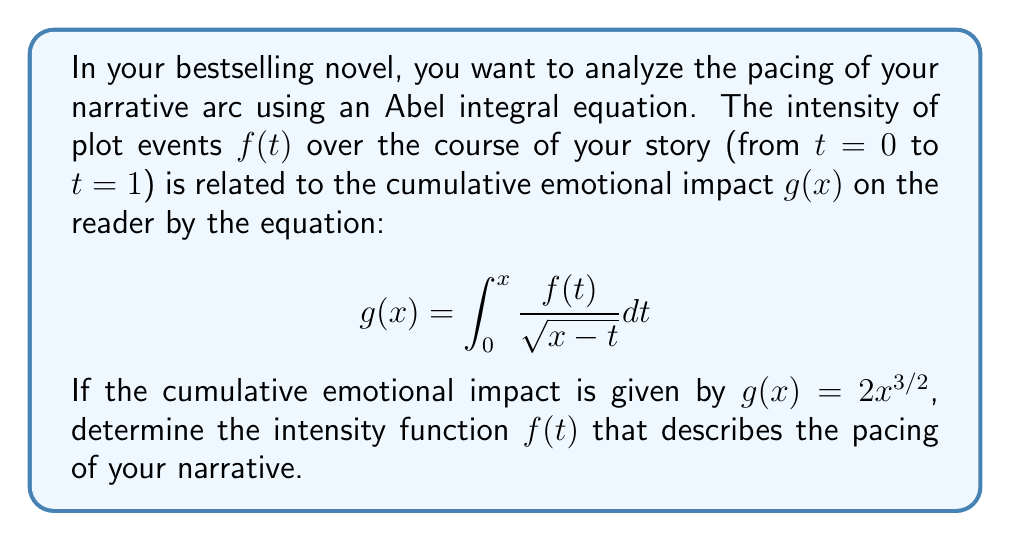Could you help me with this problem? To solve this Abel integral equation and find $f(t)$, we'll follow these steps:

1) The general form of an Abel integral equation is:

   $$g(x) = \int_0^x \frac{f(t)}{\sqrt{x-t}} dt$$

2) The solution to this equation is given by:

   $$f(t) = \frac{1}{\pi} \frac{d}{dt} \int_0^t \frac{g'(x)}{\sqrt{t-x}} dx$$

3) In our case, $g(x) = 2x^{3/2}$. We need to find $g'(x)$:

   $$g'(x) = 3x^{1/2}$$

4) Now, let's substitute this into our solution formula:

   $$f(t) = \frac{1}{\pi} \frac{d}{dt} \int_0^t \frac{3x^{1/2}}{\sqrt{t-x}} dx$$

5) To evaluate this, we can use the substitution $x = t\sin^2\theta$, $dx = 2t\sin\theta\cos\theta d\theta$:

   $$f(t) = \frac{3}{\pi} \frac{d}{dt} \int_0^{\pi/2} \frac{(t\sin^2\theta)^{1/2}}{\sqrt{t-t\sin^2\theta}} 2t\sin\theta\cos\theta d\theta$$

6) Simplifying:

   $$f(t) = \frac{3}{\pi} \frac{d}{dt} \int_0^{\pi/2} 2t\sin^2\theta d\theta$$

7) Evaluating the integral:

   $$f(t) = \frac{3}{\pi} \frac{d}{dt} [t\pi/2]$$

8) Taking the derivative:

   $$f(t) = \frac{3}{\pi} [\pi/2] = \frac{3}{2}$$

Therefore, the intensity function $f(t)$ is constant and equal to $\frac{3}{2}$.
Answer: $f(t) = \frac{3}{2}$ 